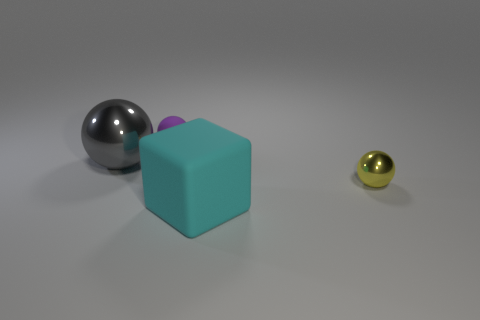Is there a large rubber cube?
Provide a short and direct response. Yes. Does the shiny ball that is right of the big gray metallic ball have the same size as the cyan object that is right of the gray shiny thing?
Offer a terse response. No. What is the material of the object that is behind the small metal sphere and in front of the small matte thing?
Keep it short and to the point. Metal. There is a large gray metallic sphere; how many purple matte objects are in front of it?
Provide a succinct answer. 0. Is there anything else that is the same size as the cyan rubber cube?
Offer a very short reply. Yes. There is a thing that is the same material as the big sphere; what color is it?
Your answer should be compact. Yellow. Do the cyan object and the small matte thing have the same shape?
Provide a succinct answer. No. How many things are in front of the purple sphere and behind the yellow sphere?
Provide a succinct answer. 1. How many matte things are big purple cylinders or large blocks?
Provide a succinct answer. 1. There is a sphere that is in front of the metallic sphere left of the purple matte thing; what is its size?
Ensure brevity in your answer.  Small. 